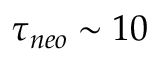Convert formula to latex. <formula><loc_0><loc_0><loc_500><loc_500>\tau _ { n e o } \sim 1 0</formula> 